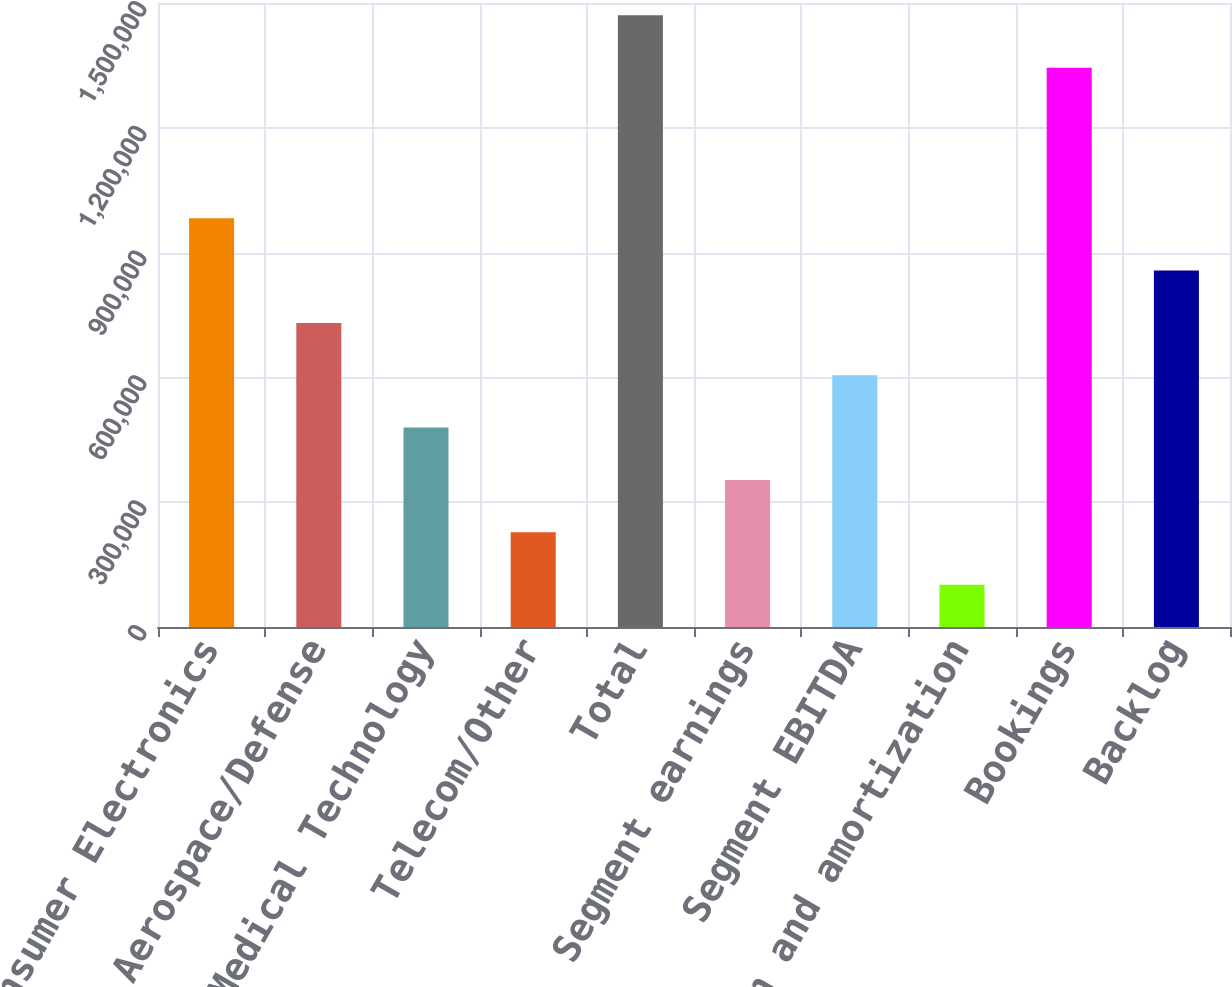Convert chart. <chart><loc_0><loc_0><loc_500><loc_500><bar_chart><fcel>Consumer Electronics<fcel>Aerospace/Defense<fcel>Medical Technology<fcel>Telecom/Other<fcel>Total<fcel>Segment earnings<fcel>Segment EBITDA<fcel>Depreciation and amortization<fcel>Bookings<fcel>Backlog<nl><fcel>982606<fcel>730958<fcel>479310<fcel>227663<fcel>1.47036e+06<fcel>353487<fcel>605134<fcel>101839<fcel>1.34454e+06<fcel>856782<nl></chart> 